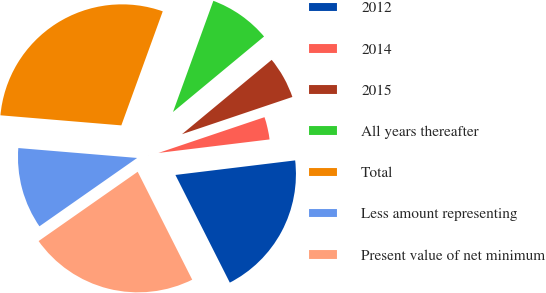Convert chart. <chart><loc_0><loc_0><loc_500><loc_500><pie_chart><fcel>2012<fcel>2014<fcel>2015<fcel>All years thereafter<fcel>Total<fcel>Less amount representing<fcel>Present value of net minimum<nl><fcel>19.48%<fcel>3.25%<fcel>5.84%<fcel>8.44%<fcel>29.22%<fcel>11.04%<fcel>22.73%<nl></chart> 